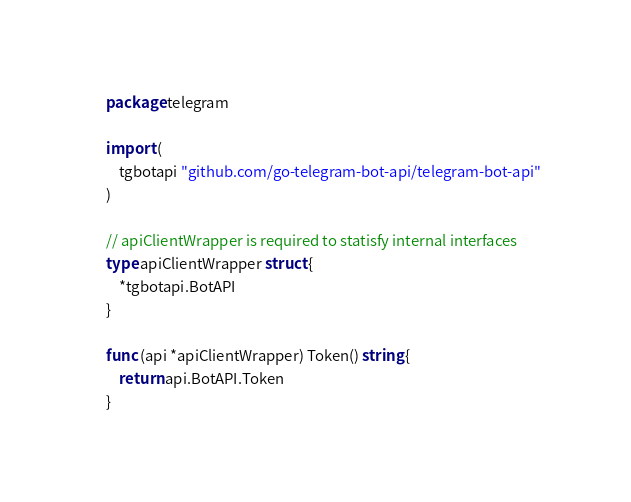<code> <loc_0><loc_0><loc_500><loc_500><_Go_>package telegram

import (
	tgbotapi "github.com/go-telegram-bot-api/telegram-bot-api"
)

// apiClientWrapper is required to statisfy internal interfaces
type apiClientWrapper struct {
	*tgbotapi.BotAPI
}

func (api *apiClientWrapper) Token() string {
	return api.BotAPI.Token
}
</code> 